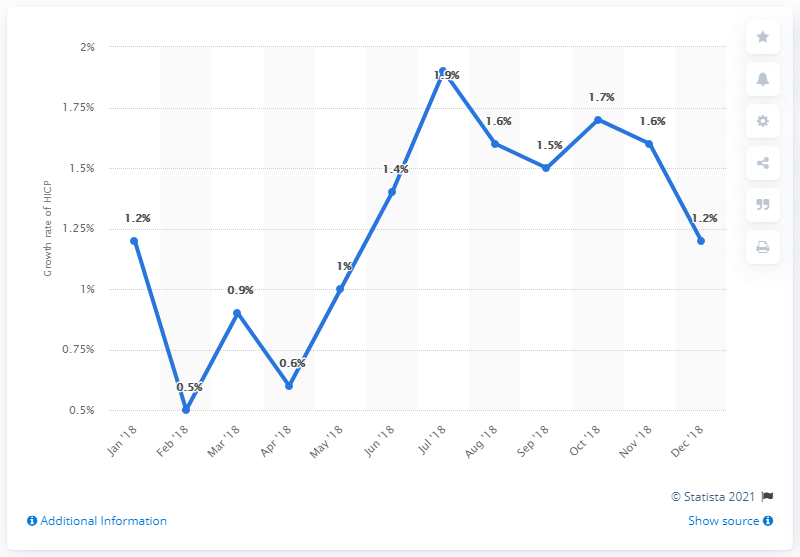Indicate a few pertinent items in this graphic. The inflation rate in December 2018 was 1.2%. 